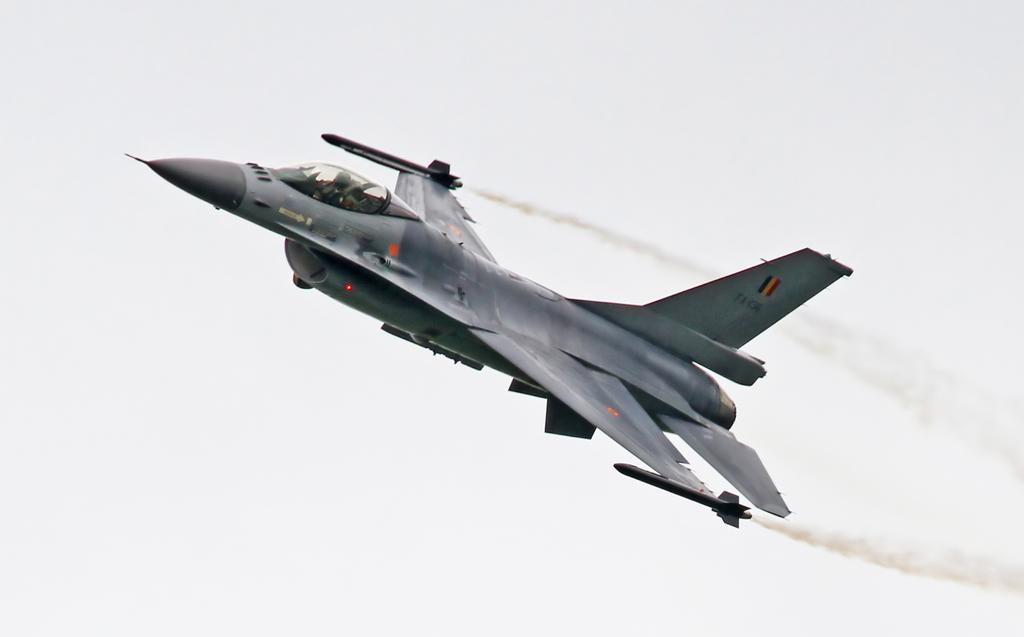What is the main subject of the image? The main subject of the image is a jet plane. What is the jet plane doing in the image? The jet plane is flying in the air. Is there any visible indication of the jet plane's activity? Yes, the jet plane is releasing smoke. Who might be inside the jet plane? There is a person in the jet plane. What can be seen in the background of the image? The sky is visible in the background of the image. What type of cabbage can be seen growing near the jet plane in the image? There is no cabbage present in the image; it features a jet plane flying in the air and releasing smoke. What behavior is exhibited by the teeth of the person inside the jet plane in the image? There is no mention of teeth or any behavior related to them in the image. 